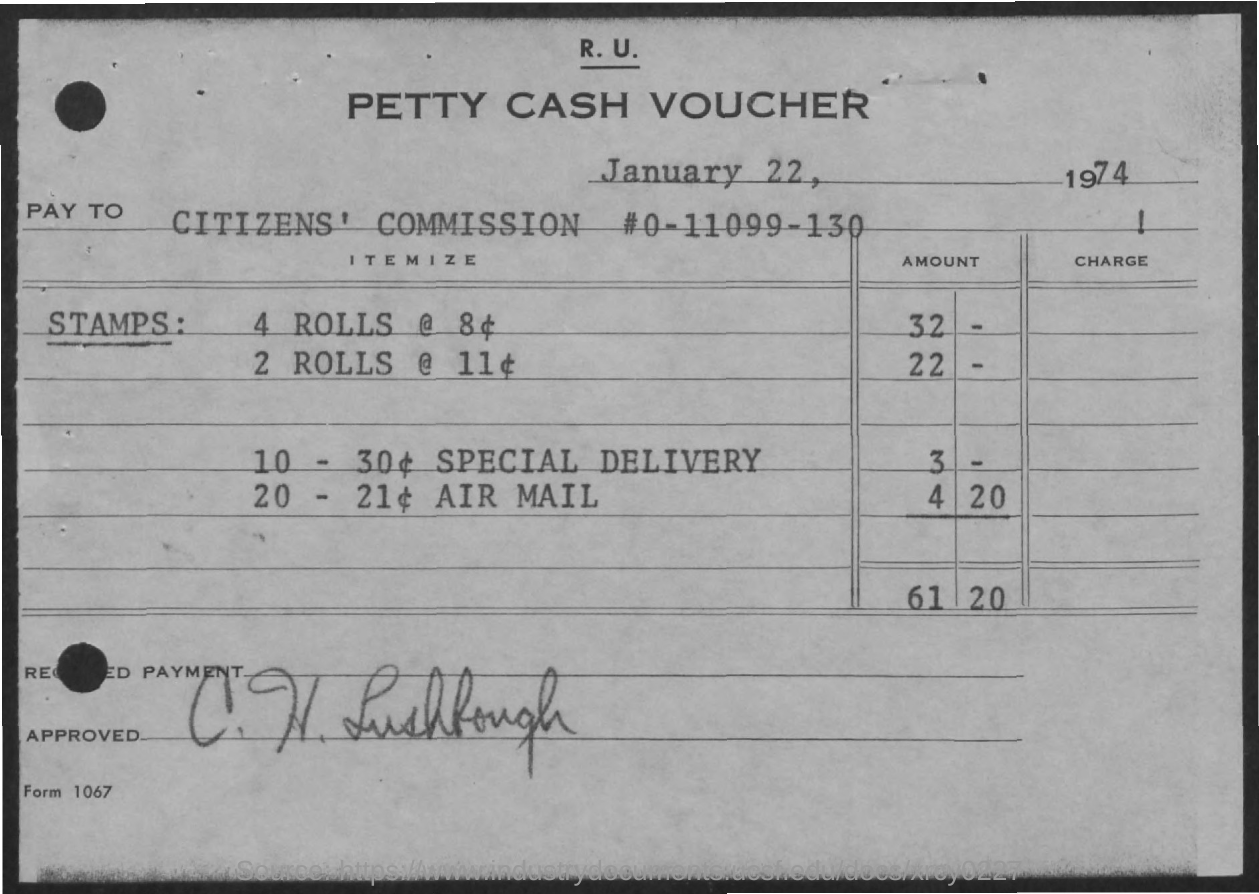List a handful of essential elements in this visual. The amount of cash voucher for special delivery is $3. On January 22, 1974, a cash voucher was issued. Petty cash vouchers are used for the purpose of facilitating small, discreet expenditures of funds within a designated amount set aside for such expenditures. The total amount for stamps is 61 dollars and 20 cents. The cost of 4 rolls is 32. 